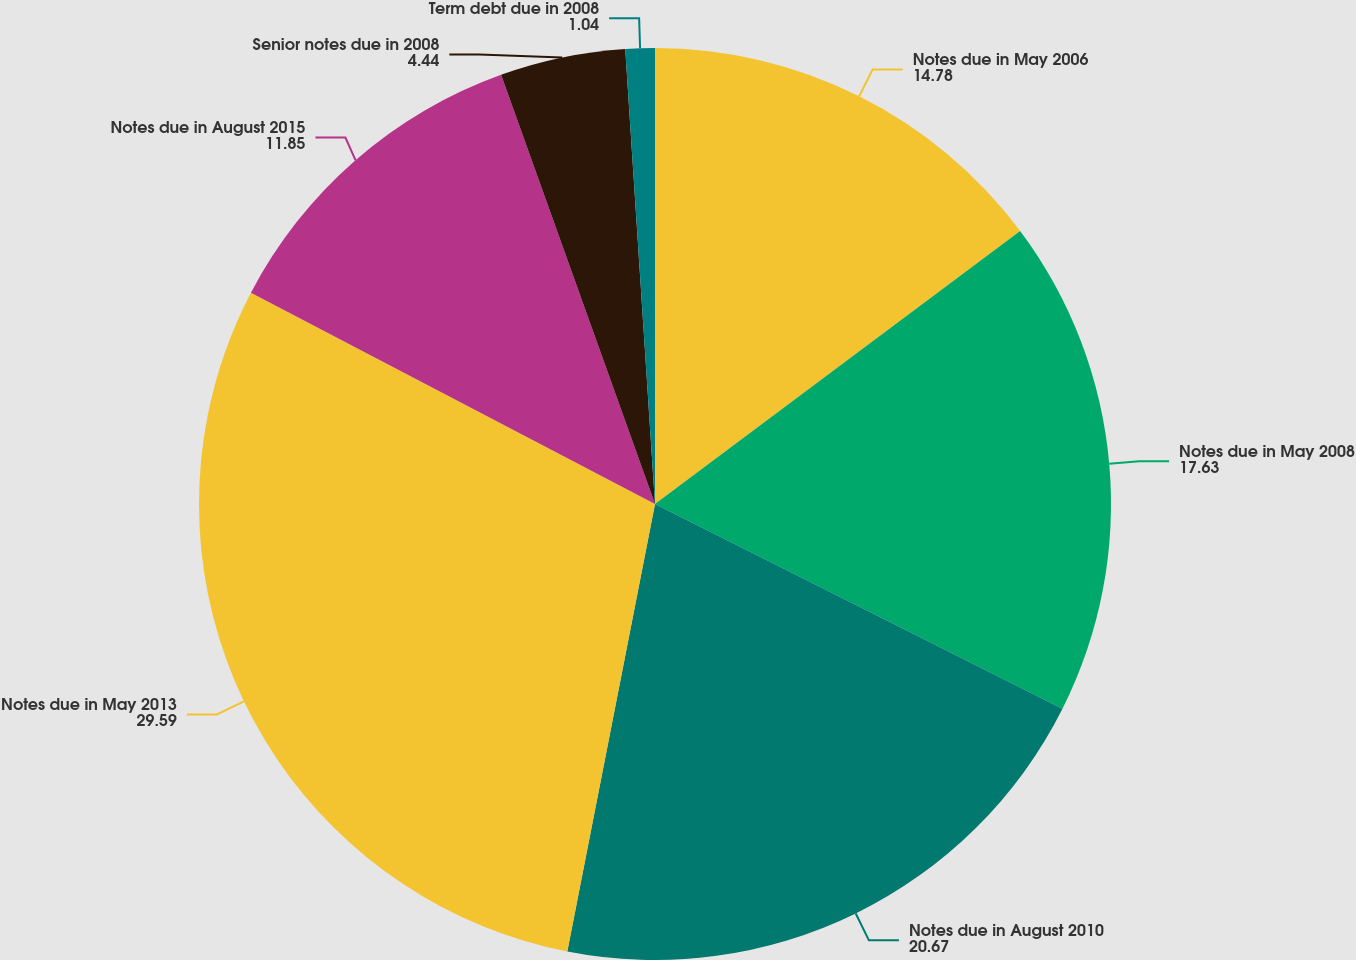<chart> <loc_0><loc_0><loc_500><loc_500><pie_chart><fcel>Notes due in May 2006<fcel>Notes due in May 2008<fcel>Notes due in August 2010<fcel>Notes due in May 2013<fcel>Notes due in August 2015<fcel>Senior notes due in 2008<fcel>Term debt due in 2008<nl><fcel>14.78%<fcel>17.63%<fcel>20.67%<fcel>29.59%<fcel>11.85%<fcel>4.44%<fcel>1.04%<nl></chart> 